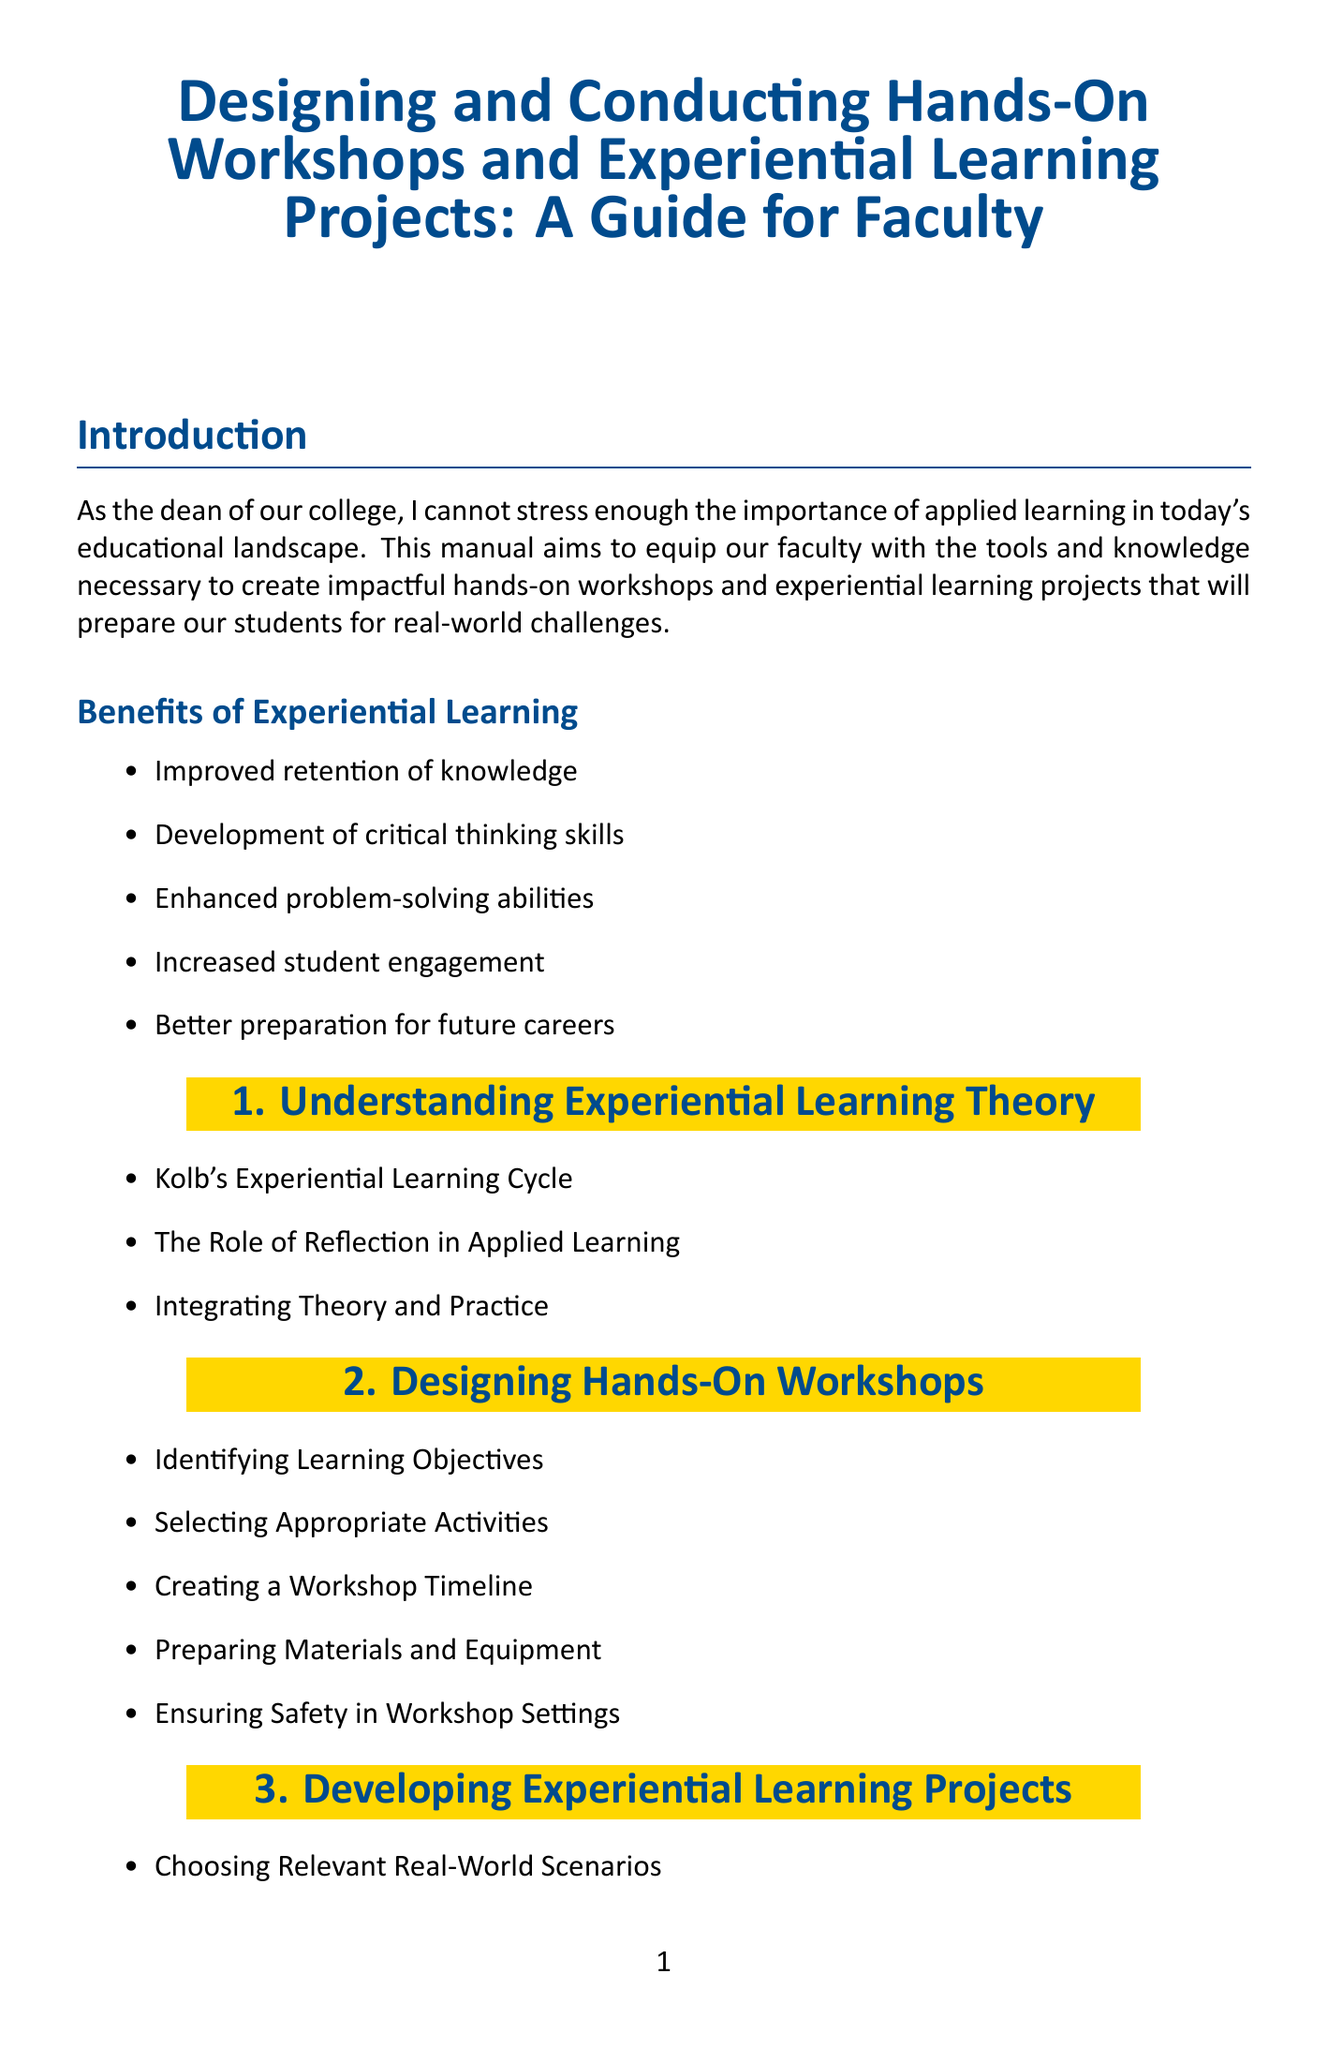what is the title of the manual? The title is mentioned explicitly at the beginning of the document.
Answer: Designing and Conducting Hands-On Workshops and Experiential Learning Projects: A Guide for Faculty what are two benefits of experiential learning? Benefits are listed in a bullet format under a specific section.
Answer: Improved retention of knowledge, Development of critical thinking skills what chapter discusses assessment strategies? The chapters of the manual are clearly delineated in the content.
Answer: Chapter 5 how many case studies are included in the manual? The case studies are enumerated in a specific section, allowing for easy counting.
Answer: 3 which book is recommended on experiential learning? The recommended books are listed under a specific resources section.
Answer: "Experience and Education" by John Dewey what is one technology integration tool mentioned? Technology integration options are listed in a section dedicated to that topic.
Answer: Virtual and Augmented Reality in Education what is a next step suggested in the conclusion? The conclusion provides a list of actionable next steps for faculty.
Answer: Form a faculty learning community focused on experiential education who is the author of the book "The Power of Experiential Learning"? The authors of the recommended books are specified in the resources section.
Answer: Colin Beard and John P. Wilson what is the role of the instructor in experiential learning? The instructor's role is described in a section of the document related to facilitation.
Answer: A Guide 